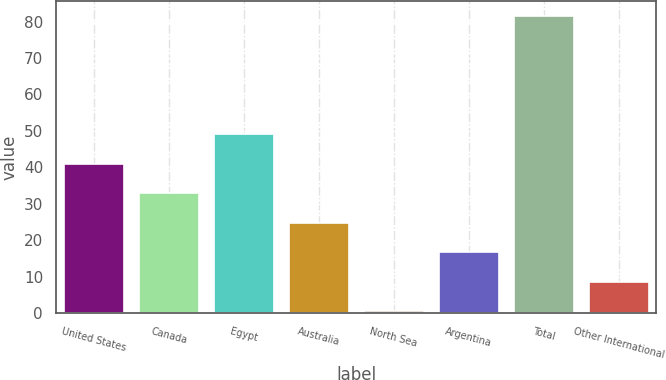Convert chart. <chart><loc_0><loc_0><loc_500><loc_500><bar_chart><fcel>United States<fcel>Canada<fcel>Egypt<fcel>Australia<fcel>North Sea<fcel>Argentina<fcel>Total<fcel>Other International<nl><fcel>41<fcel>32.9<fcel>49.2<fcel>24.8<fcel>0.5<fcel>16.7<fcel>81.5<fcel>8.6<nl></chart> 